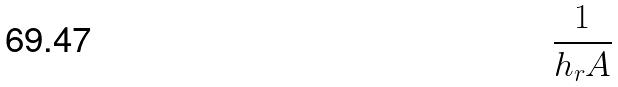<formula> <loc_0><loc_0><loc_500><loc_500>\frac { 1 } { h _ { r } A }</formula> 